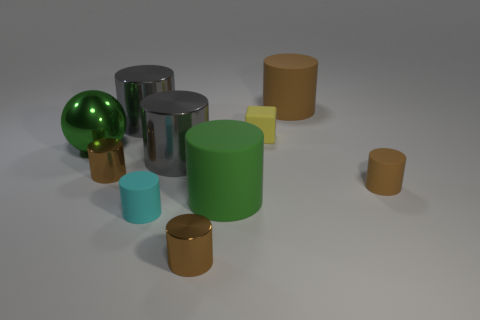Subtract all brown cylinders. How many were subtracted if there are1brown cylinders left? 3 Subtract all red spheres. How many brown cylinders are left? 4 Subtract all big brown rubber cylinders. How many cylinders are left? 7 Subtract all balls. How many objects are left? 9 Subtract 2 cylinders. How many cylinders are left? 6 Add 5 tiny cylinders. How many tiny cylinders exist? 9 Subtract all green cylinders. How many cylinders are left? 7 Subtract 0 blue spheres. How many objects are left? 10 Subtract all red cylinders. Subtract all purple spheres. How many cylinders are left? 8 Subtract all tiny cyan matte cylinders. Subtract all large metallic balls. How many objects are left? 8 